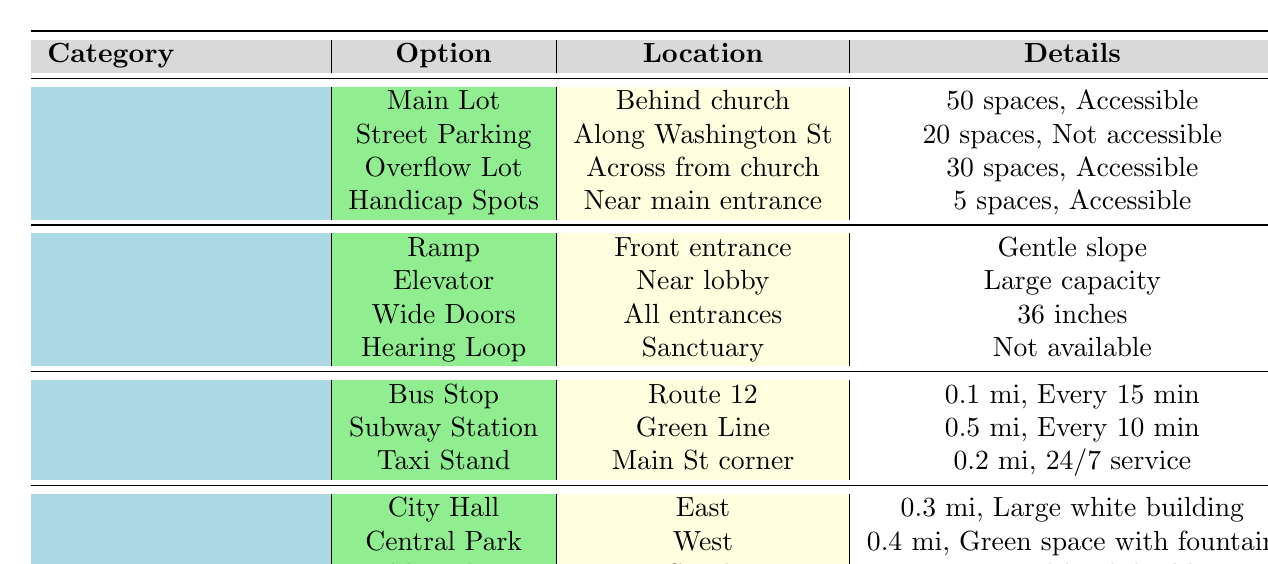What parking options are available at First Missionary Baptist Church? The table lists four parking options: Main Lot, Street Parking, Overflow Lot, and Handicap Spots.
Answer: Main Lot, Street Parking, Overflow Lot, Handicap Spots How many accessible parking spaces are there in total? The accessible parking spaces are in the Main Lot (50), Overflow Lot (30), and Handicap Spots (5). Adding these gives 50 + 30 + 5 = 85.
Answer: 85 Is there a ramp available for accessibility? The table indicates a ramp is available at the front entrance and has a gentle slope, making it accessible.
Answer: Yes Where is the nearest public transport option? The nearest public transport option is the Bus Stop, located 0.1 miles away on Route 12.
Answer: Bus Stop How many total parking spaces are available at the church? The total parking spaces are found by summing all spaces: Main Lot (50) + Street Parking (20) + Overflow Lot (30) + Handicap Spots (5) = 105.
Answer: 105 Are there any hearing loop facilities available for accessibility? According to the table, a hearing loop is not available in the sanctuary.
Answer: No What is the distance to the Public Library from the church? The distance to the Public Library, as indicated in the table, is 0.2 miles to the south.
Answer: 0.2 miles Which parking options are accessible? The accessible parking options are Main Lot, Overflow Lot, and Handicap Spots.
Answer: Main Lot, Overflow Lot, Handicap Spots Is the Subway Station further away than the Bus Stop? The table shows the Subway Station is 0.5 miles away and the Bus Stop is 0.1 miles away, thus Subway Station is further away.
Answer: Yes How many more spaces does the Main Lot have compared to the Overflow Lot? The Main Lot has 50 spaces and the Overflow Lot has 30 spaces. The difference is 50 - 30 = 20 spaces more.
Answer: 20 spaces more 